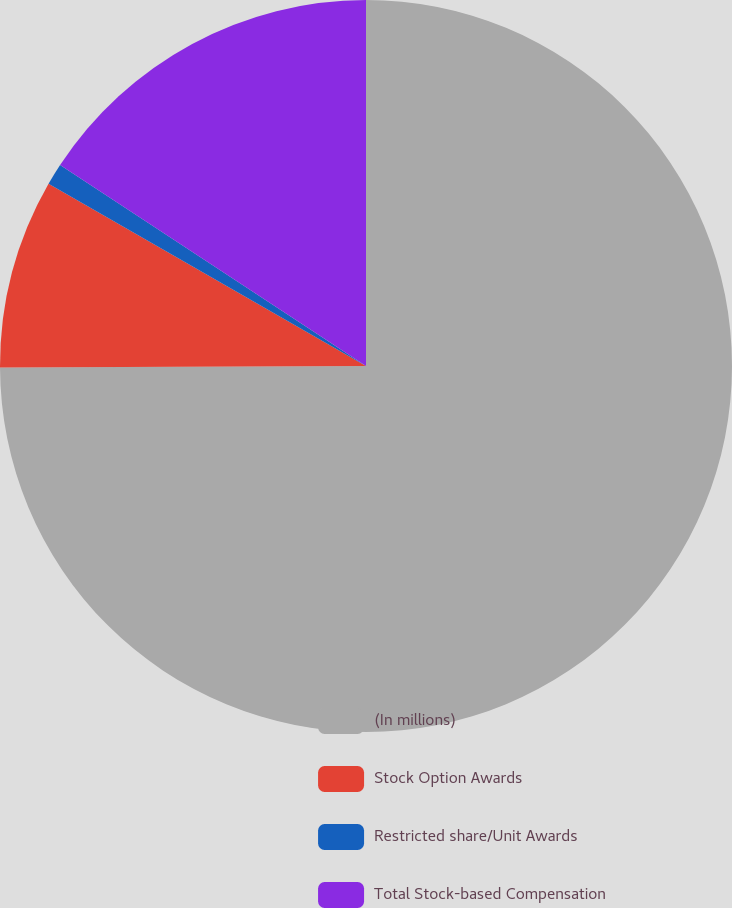<chart> <loc_0><loc_0><loc_500><loc_500><pie_chart><fcel>(In millions)<fcel>Stock Option Awards<fcel>Restricted share/Unit Awards<fcel>Total Stock-based Compensation<nl><fcel>74.93%<fcel>8.36%<fcel>0.96%<fcel>15.75%<nl></chart> 